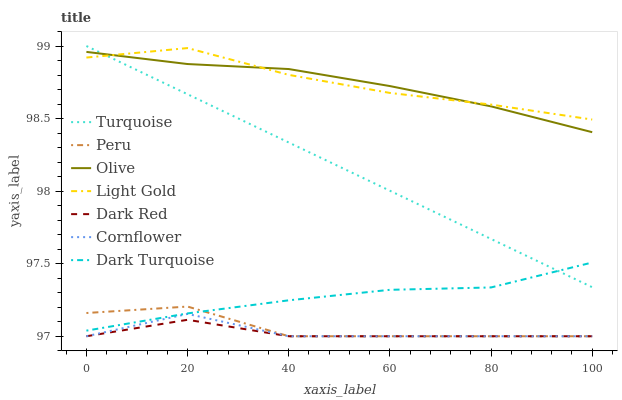Does Dark Red have the minimum area under the curve?
Answer yes or no. Yes. Does Light Gold have the maximum area under the curve?
Answer yes or no. Yes. Does Turquoise have the minimum area under the curve?
Answer yes or no. No. Does Turquoise have the maximum area under the curve?
Answer yes or no. No. Is Turquoise the smoothest?
Answer yes or no. Yes. Is Cornflower the roughest?
Answer yes or no. Yes. Is Dark Red the smoothest?
Answer yes or no. No. Is Dark Red the roughest?
Answer yes or no. No. Does Cornflower have the lowest value?
Answer yes or no. Yes. Does Turquoise have the lowest value?
Answer yes or no. No. Does Turquoise have the highest value?
Answer yes or no. Yes. Does Dark Red have the highest value?
Answer yes or no. No. Is Dark Turquoise less than Light Gold?
Answer yes or no. Yes. Is Dark Turquoise greater than Dark Red?
Answer yes or no. Yes. Does Olive intersect Light Gold?
Answer yes or no. Yes. Is Olive less than Light Gold?
Answer yes or no. No. Is Olive greater than Light Gold?
Answer yes or no. No. Does Dark Turquoise intersect Light Gold?
Answer yes or no. No. 